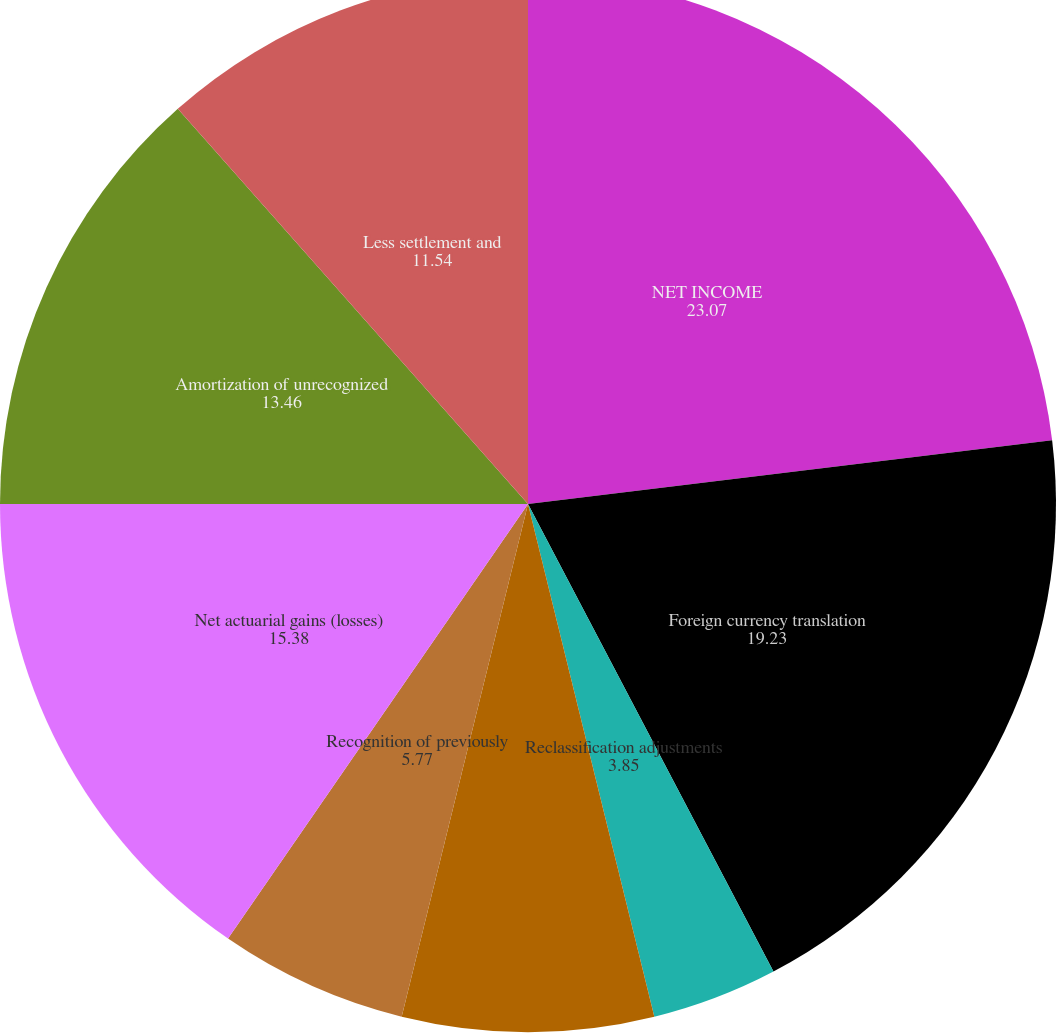<chart> <loc_0><loc_0><loc_500><loc_500><pie_chart><fcel>NET INCOME<fcel>Foreign currency translation<fcel>Reclassification adjustments<fcel>Changes in fair value of<fcel>Recognition of previously<fcel>Income tax effect<fcel>Net actuarial gains (losses)<fcel>Amortization of unrecognized<fcel>Less settlement and<nl><fcel>23.07%<fcel>19.23%<fcel>3.85%<fcel>7.69%<fcel>5.77%<fcel>0.0%<fcel>15.38%<fcel>13.46%<fcel>11.54%<nl></chart> 